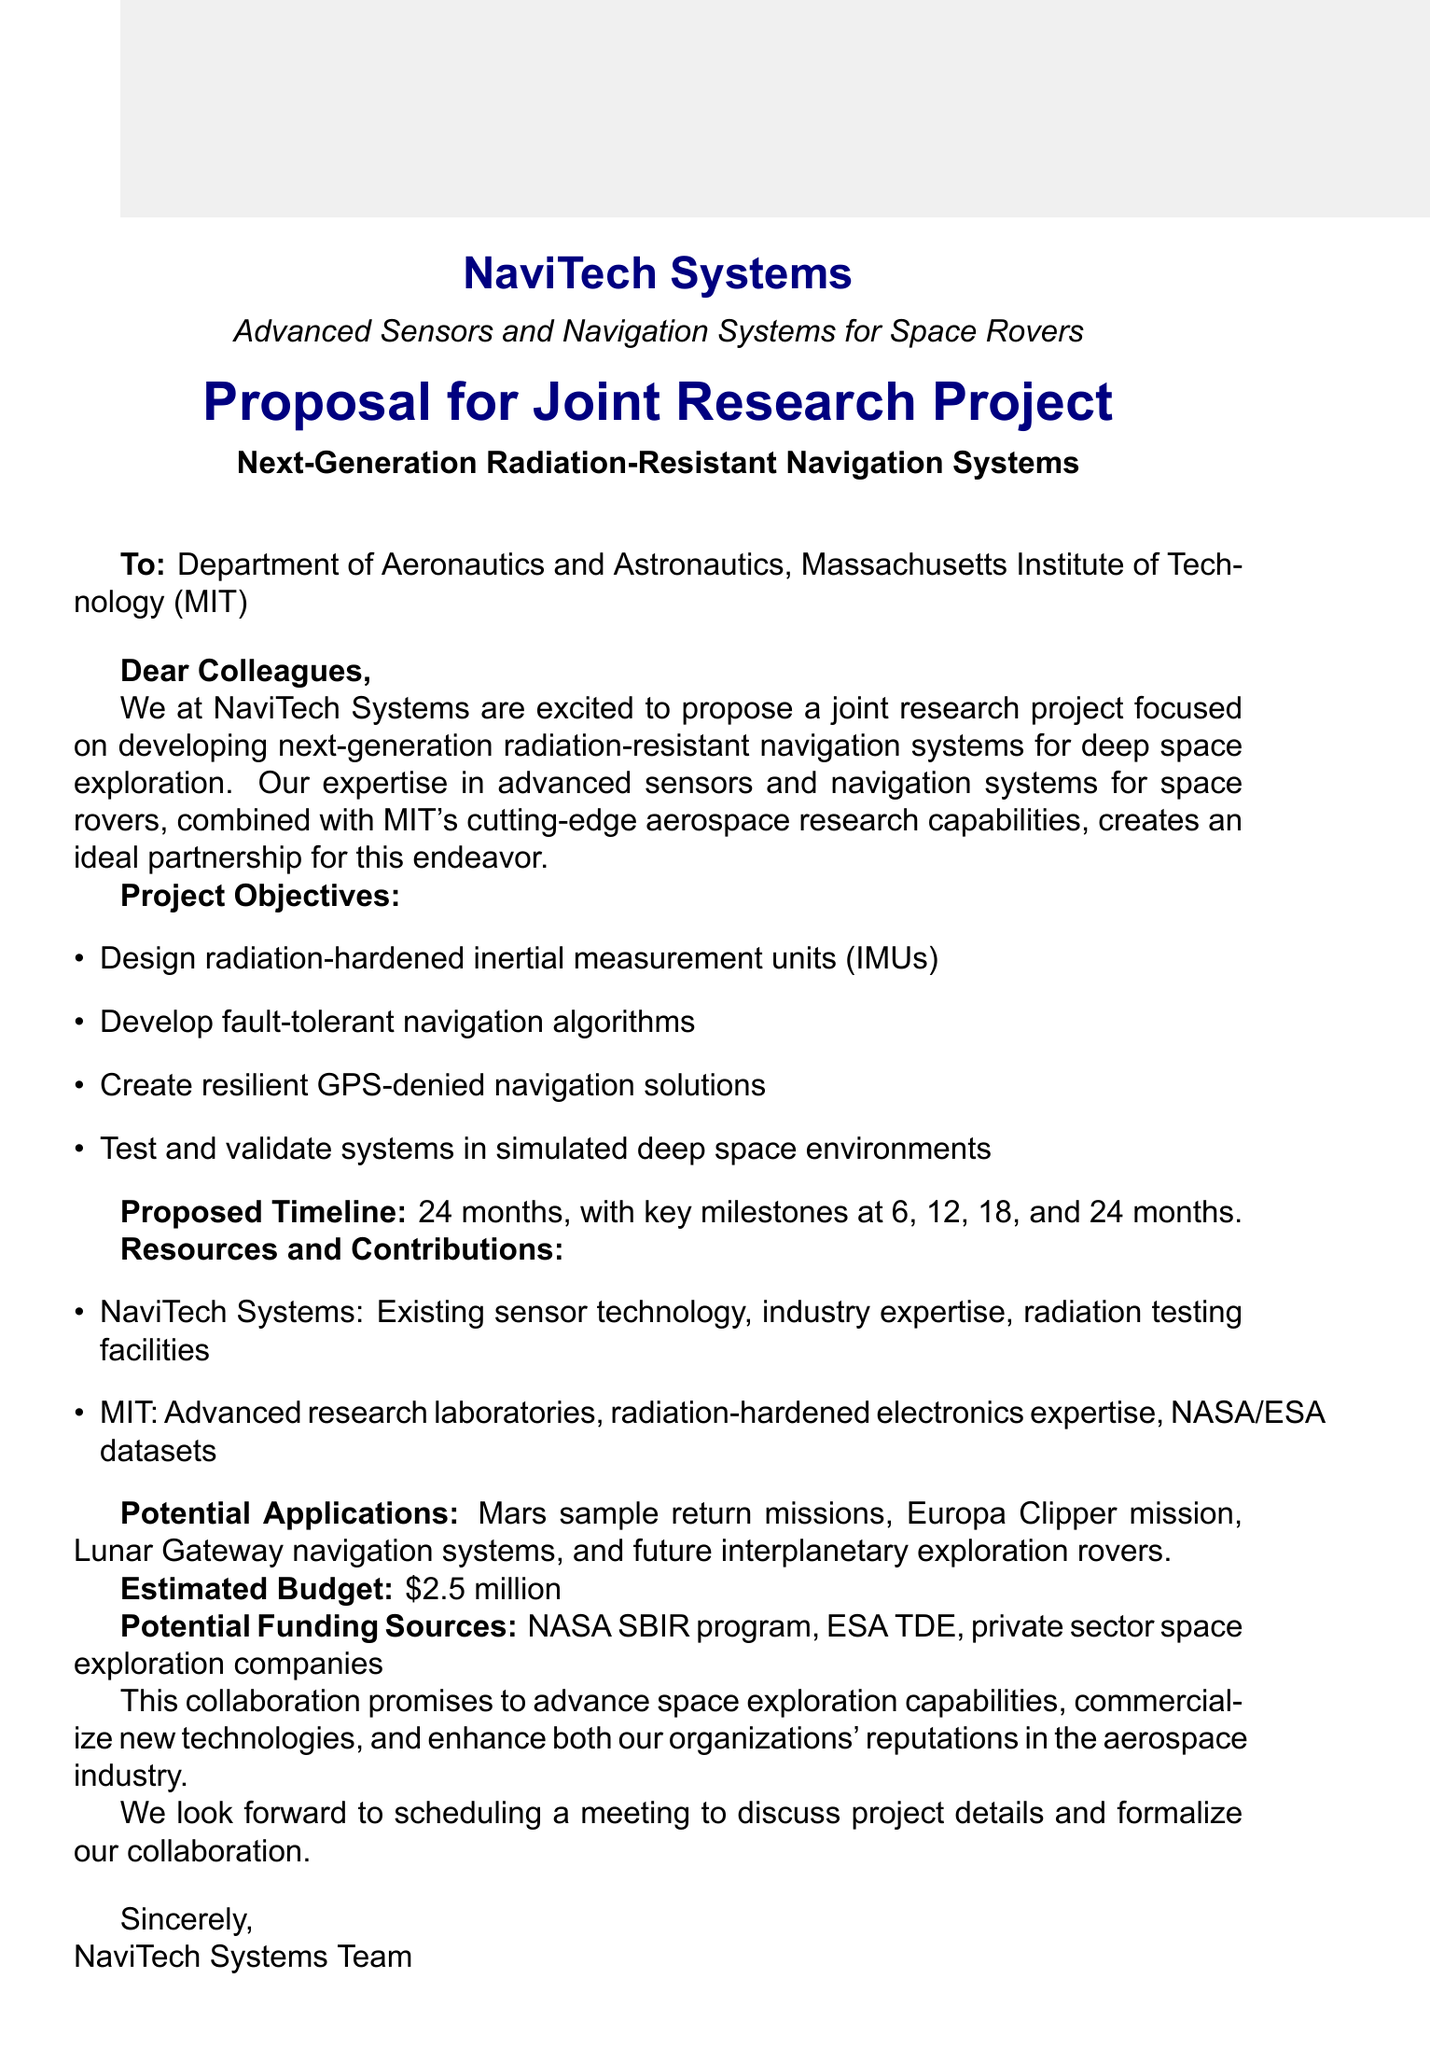what is the subject of the proposal? The subject is clearly stated at the beginning of the document, focusing on the research collaboration.
Answer: Proposal for Joint Research Project: Next-Gen Radiation-Resistant Navigation Systems who is the proposed university partner? The document lists the university partner in the context of the joint project proposal.
Answer: Massachusetts Institute of Technology (MIT) how long is the proposed project duration? The duration is specified in the timeline section of the document.
Answer: 24 months what are the key milestones planned for the project? The key milestones are listed in the proposed timeline section, indicating significant project phases.
Answer: Month 6: Conceptual design completion, Month 12: Prototype development, Month 18: Laboratory testing, Month 24: Final report and recommendations what is the estimated budget for the project? The budget is provided in the funding and support section of the document.
Answer: $2.5 million what type of testing facilities will NaviTech Systems provide? The document mentions specific resources and contributions that NaviTech will offer for the project.
Answer: Testing facilities for radiation exposure what potential applications are mentioned in the proposal? The potential applications section lists specific missions where the developed technology may be utilized.
Answer: Mars sample return missions, Europa Clipper mission, Lunar Gateway navigation systems, Future interplanetary exploration rovers what next steps are suggested in the conclusion? The conclusion section indicates what actions should follow this proposal.
Answer: Schedule a meeting to discuss project details and formalize the collaboration what expertise will MIT contribute to the project? The contributions from MIT are outlined in the resources and contributions section.
Answer: Advanced research laboratories, Expertise in radiation-hardened electronics, Access to NASA and ESA datasets 